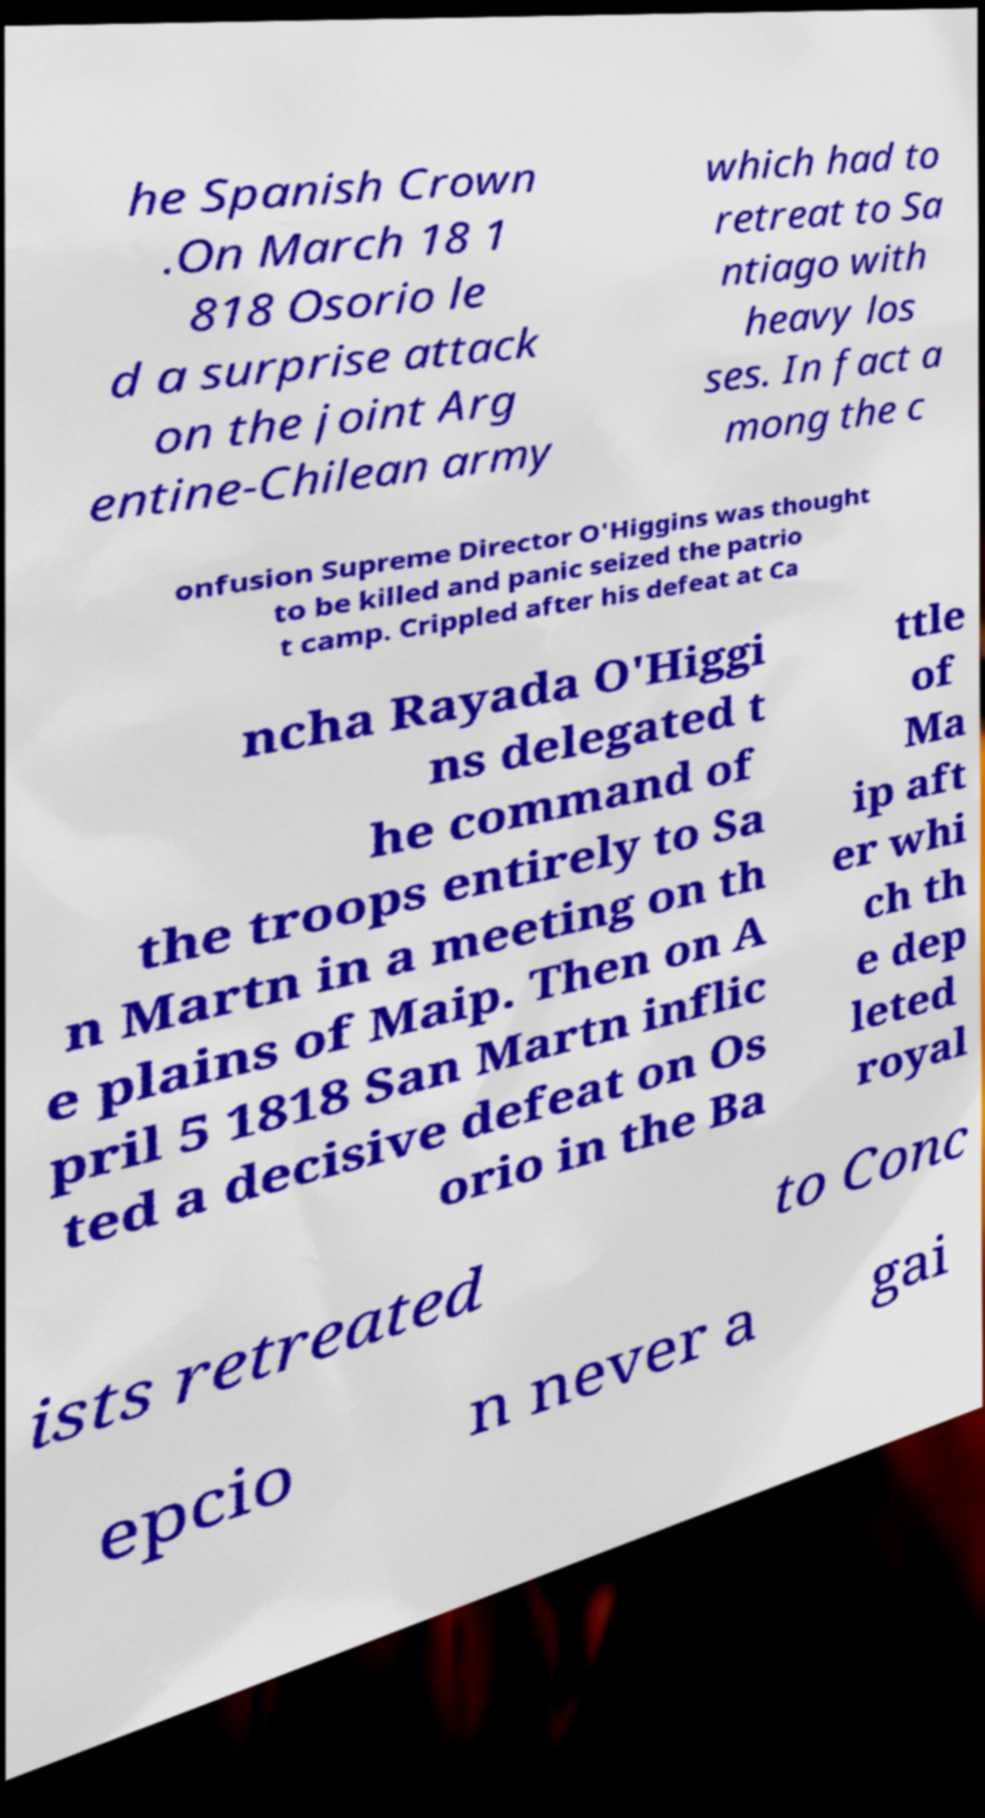I need the written content from this picture converted into text. Can you do that? he Spanish Crown .On March 18 1 818 Osorio le d a surprise attack on the joint Arg entine-Chilean army which had to retreat to Sa ntiago with heavy los ses. In fact a mong the c onfusion Supreme Director O'Higgins was thought to be killed and panic seized the patrio t camp. Crippled after his defeat at Ca ncha Rayada O'Higgi ns delegated t he command of the troops entirely to Sa n Martn in a meeting on th e plains of Maip. Then on A pril 5 1818 San Martn inflic ted a decisive defeat on Os orio in the Ba ttle of Ma ip aft er whi ch th e dep leted royal ists retreated to Conc epcio n never a gai 